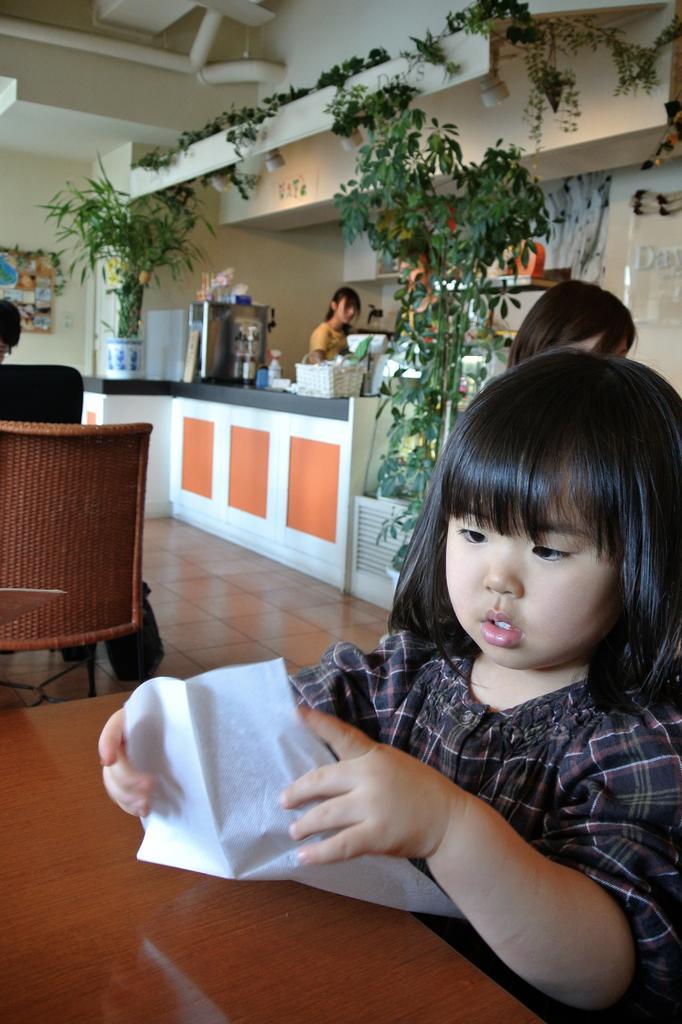How would you summarize this image in a sentence or two? In this image I can see a girl sitting on the chair and there is a table. At the back side there is a flower pot. 